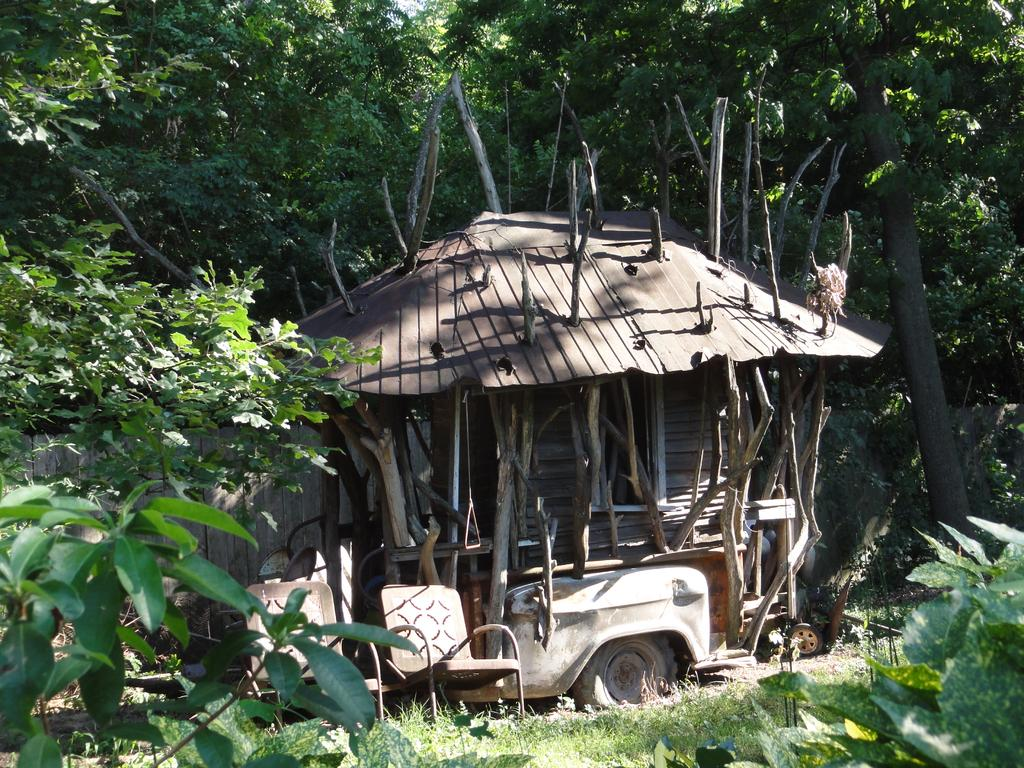What type of furniture is present in the image? There are chairs in the image. What type of structure can be seen in the image? There is a shed in the image. What can be seen in the background of the image? There are trees in the background of the image. Reasoning: Let'g: Let's think step by step in order to produce the conversation. We start by identifying the main subjects and objects in the image based on the provided facts. We then formulate questions that focus on the location and characteristics of these subjects and objects, ensuring that each question can be answered definitively with the information given. We avoid yes/no questions and ensure that the language is simple and clear. Absurd Question/Answer: What type of bells can be heard ringing in the image? There are no bells present in the image, and therefore no sound can be heard. Is the thumb visible in the image? There is no thumb visible in the image. 